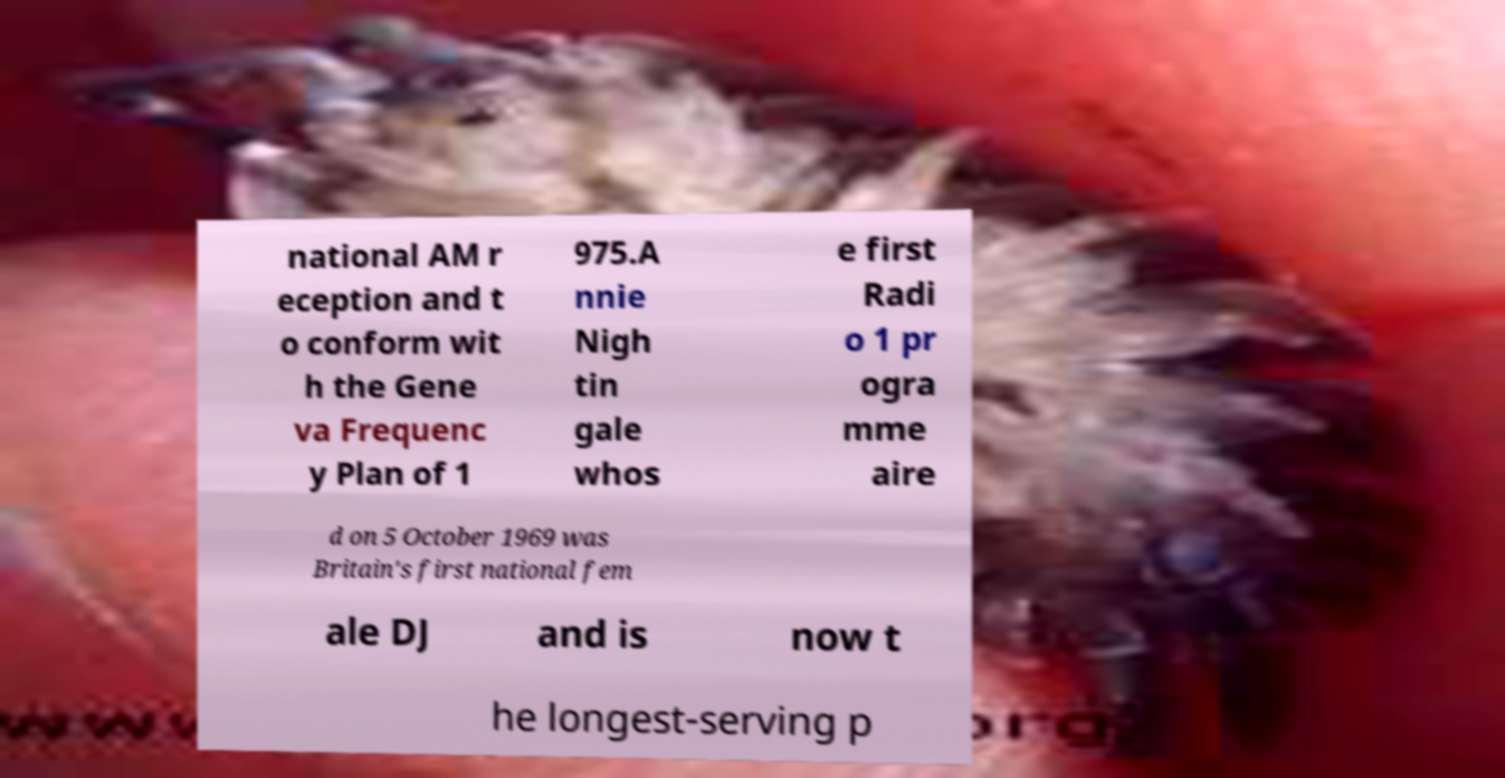Could you extract and type out the text from this image? national AM r eception and t o conform wit h the Gene va Frequenc y Plan of 1 975.A nnie Nigh tin gale whos e first Radi o 1 pr ogra mme aire d on 5 October 1969 was Britain's first national fem ale DJ and is now t he longest-serving p 